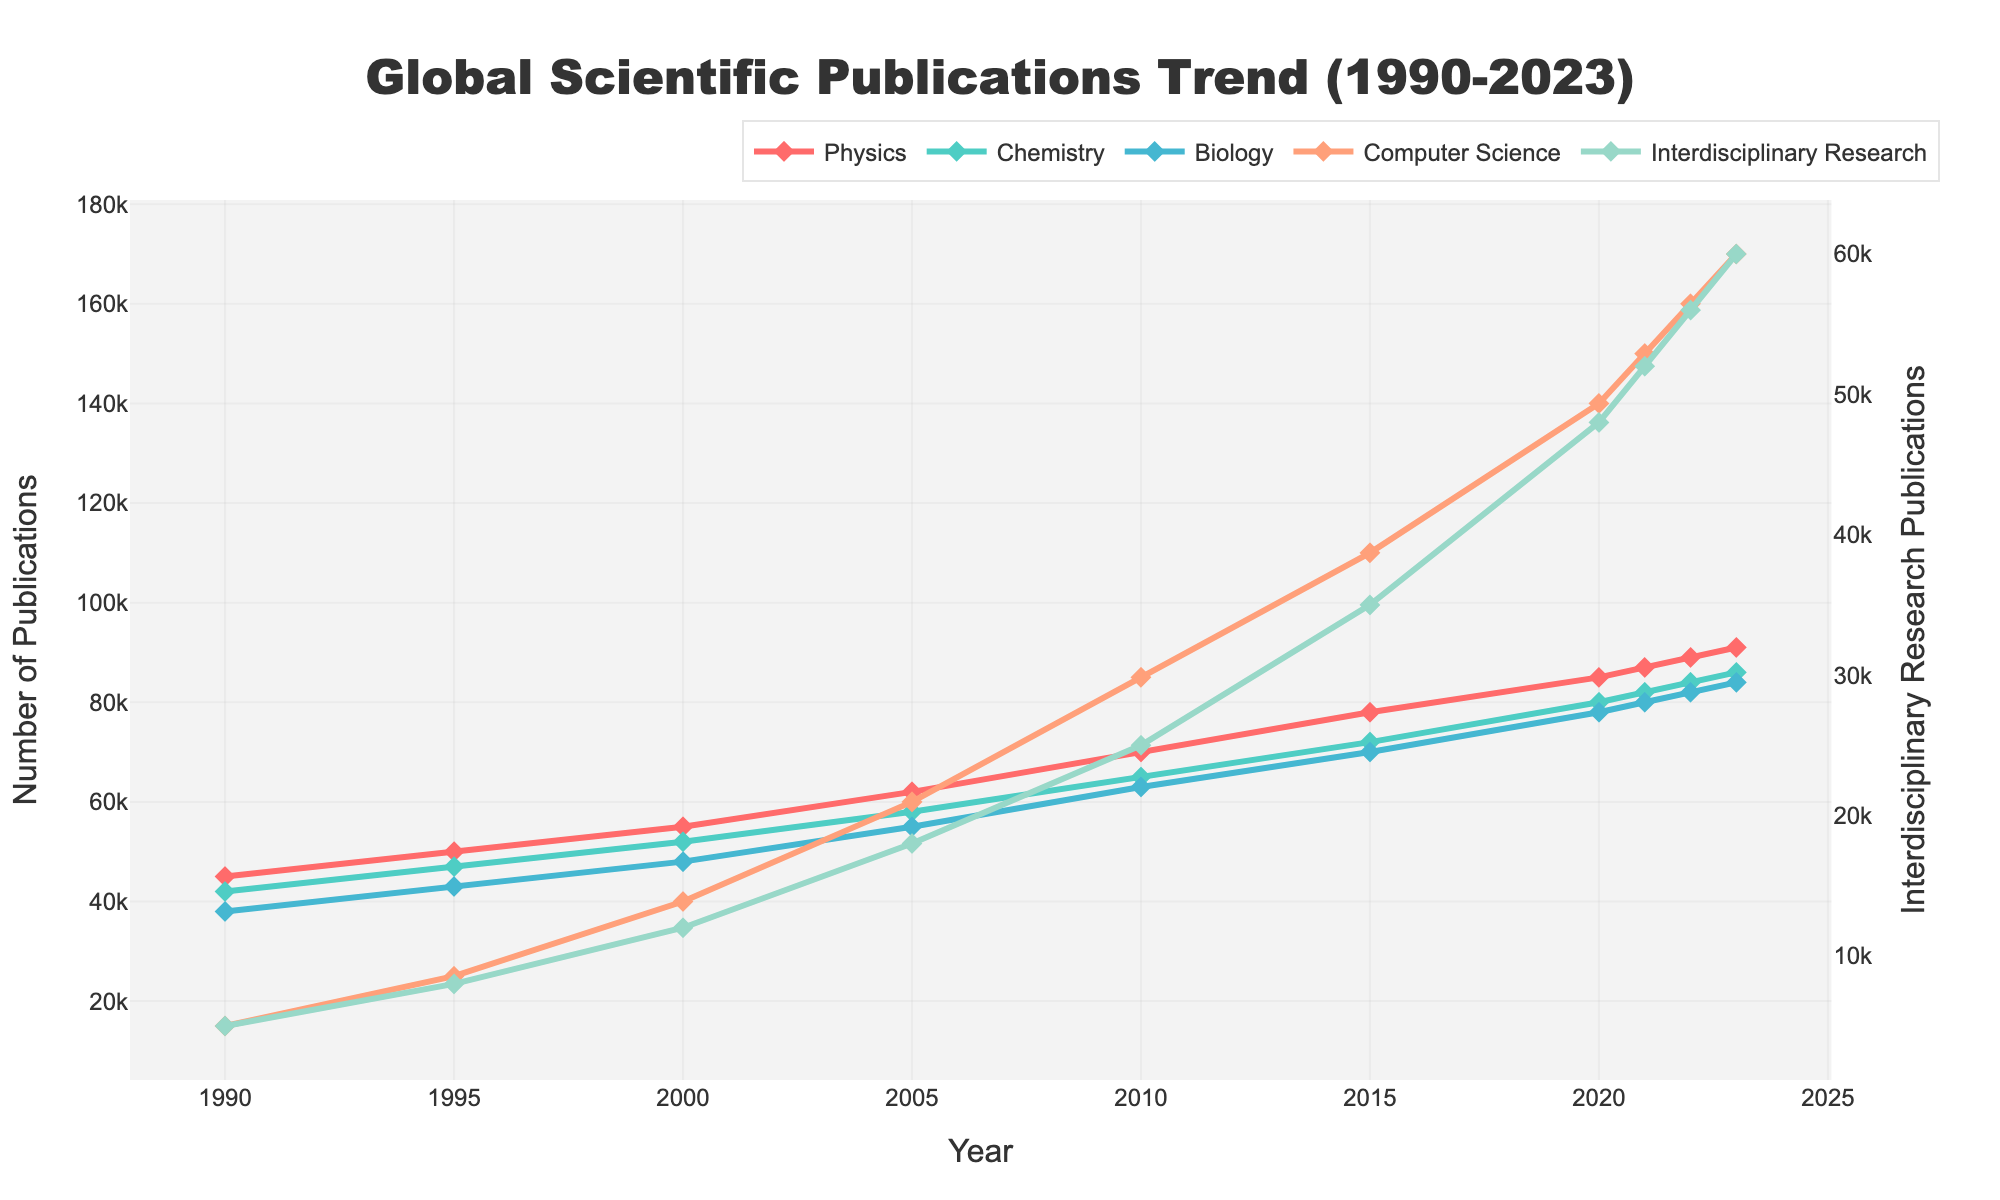What is the overall trend in the number of publications in Computer Science from 1990 to 2023? The plot shows a consistent upward trend in Computer Science publications. Beginning with 15,000 in 1990, the count climbs steadily, reaching 170,000 in 2023.
Answer: Upward trend How many more publications were there in Biology than in Chemistry in the year 2023? In 2023, Biology had 84,000 publications while Chemistry had 86,000. So, the difference is: 86,000 - 84,000. This equates to 2,000 more publications in Chemistry than in Biology.
Answer: -2,000 (indicating more in Chemistry) Which discipline showed the sharpest increase in publications between 1990 and 2023? Comparing the initial and final counts for each discipline: Physics (from 45,000 to 91,000), Chemistry (from 42,000 to 86,000), Biology (from 38,000 to 84,000), Computer Science (from 15,000 to 170,000), Interdisciplinary Research (from 5,000 to 60,000). Computer Science shows the largest increase, from 15,000 to 170,000.
Answer: Computer Science In which year did Interdisciplinary Research publications surpass 30,000? By examining the Interdisciplinary Research line, it surpassed 30,000 publications in 2015 where it reached 35,000.
Answer: 2015 How did the number of Interdisciplinary Research publications in 2023 compare to Biology publications in 2000? In 2023, Interdisciplinary Research had 60,000 publications, while Biology had 48,000 publications in 2000. Comparing these numbers: 60,000 - 48,000 = 12,000 more in Interdisciplinary Research in 2023.
Answer: 12,000 more Which discipline had the smallest growth in publications between 1990 and 2023? Comparing the growth for each discipline: Physics (+46,000), Chemistry (+44,000), Biology (+46,000), Computer Science (+155,000), Interdisciplinary Research (+55,000). Chemistry had the smallest growth, from 42,000 in 1990 to 86,000 in 2023.
Answer: Chemistry What is the color associated with Chemistry publications in the plot? The color used for Chemistry publications is turquoise.
Answer: Turquoise What is the difference in the number of Computer Science publications between 2015 and 2023? In 2015, Computer Science had 110,000 publications; by 2023, this rose to 170,000. The difference is: 170,000 - 110,000 = 60,000.
Answer: 60,000 By how much did Interdisciplinary Research publications increase from 1990 to 2023? Interdisciplinary Research publications increased from 5,000 in 1990 to 60,000 in 2023. The increase is: 60,000 - 5,000 = 55,000.
Answer: 55,000 In which year did Chemistry publications reach 80,000? Inspecting the Chemistry plot, it reached 80,000 publications in 2020.
Answer: 2020 